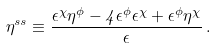<formula> <loc_0><loc_0><loc_500><loc_500>\eta ^ { s s } \equiv \frac { \epsilon ^ { \chi } \eta ^ { \phi } - 4 \epsilon ^ { \phi } \epsilon ^ { \chi } + \epsilon ^ { \phi } \eta ^ { \chi } } { \epsilon } \, .</formula> 